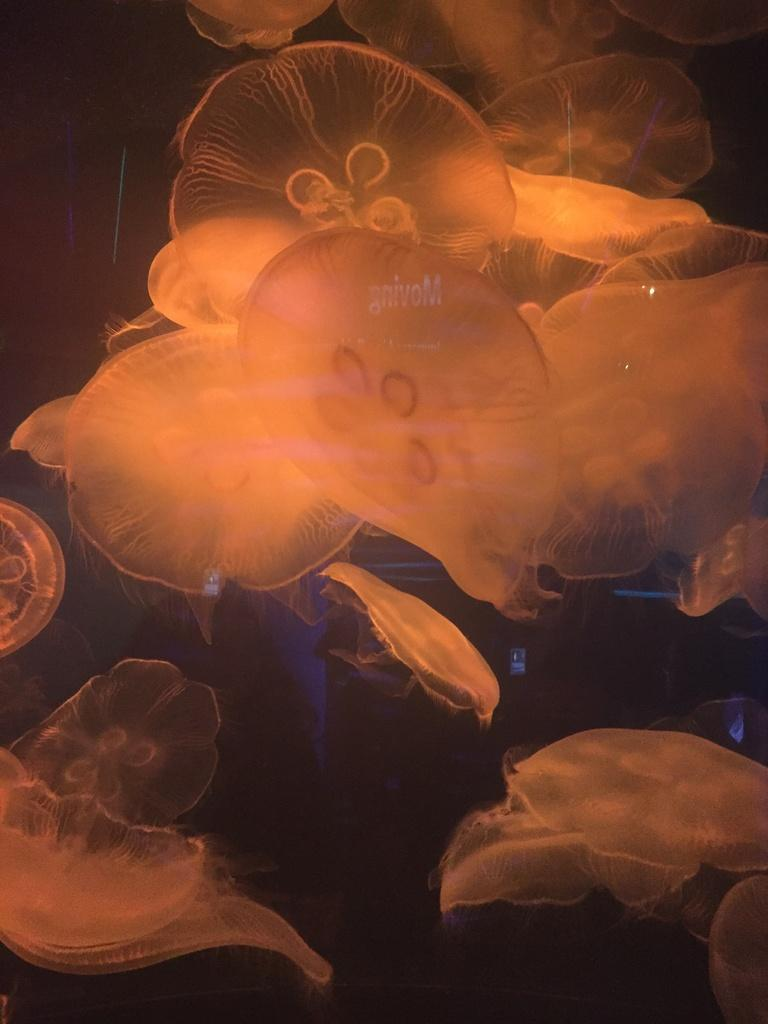What type of animals are present in the image? There are jellyfishes in the image. Can you describe the appearance of the jellyfishes? The jellyfishes have a translucent, gelatinous body and long, trailing tentacles. What might be the natural habitat of these jellyfishes? Jellyfishes are typically found in oceans and seas. What grade did the pancake receive in the image? There is no pancake present in the image, and therefore no grade can be assigned. 